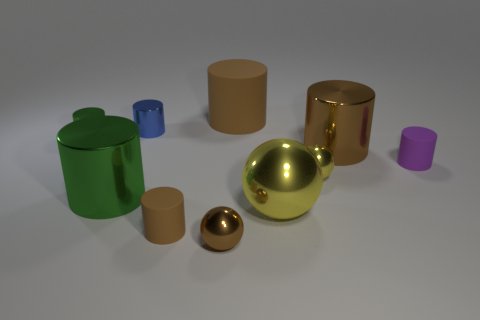There is another ball that is the same color as the big sphere; what material is it?
Offer a very short reply. Metal. Is the number of brown rubber cylinders greater than the number of purple matte things?
Ensure brevity in your answer.  Yes. How many other things are made of the same material as the purple cylinder?
Your response must be concise. 2. What is the shape of the green shiny thing that is behind the matte thing that is on the right side of the large cylinder that is behind the blue thing?
Give a very brief answer. Cylinder. Is the number of large yellow balls behind the tiny yellow shiny object less than the number of purple objects behind the big rubber thing?
Offer a terse response. No. Are there any large spheres of the same color as the large matte thing?
Keep it short and to the point. No. Is the material of the large green object the same as the blue object that is to the left of the brown sphere?
Provide a short and direct response. Yes. Are there any blue metallic things in front of the brown matte object in front of the tiny purple matte cylinder?
Offer a terse response. No. What color is the small object that is both behind the small yellow metal sphere and on the right side of the large shiny ball?
Your answer should be compact. Purple. The purple object is what size?
Ensure brevity in your answer.  Small. 